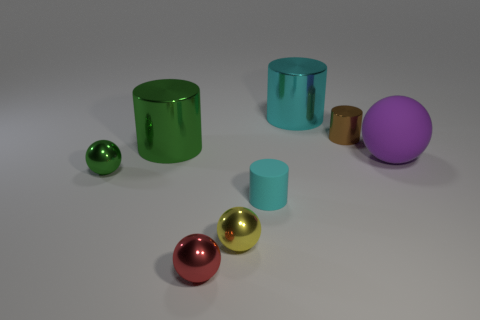Subtract all large cyan metallic cylinders. How many cylinders are left? 3 Add 1 brown shiny things. How many objects exist? 9 Subtract all cyan cylinders. How many cylinders are left? 2 Subtract all purple cubes. How many yellow balls are left? 1 Subtract all cyan balls. Subtract all blue blocks. How many balls are left? 4 Subtract all green objects. Subtract all purple rubber objects. How many objects are left? 5 Add 6 tiny cyan rubber objects. How many tiny cyan rubber objects are left? 7 Add 5 small yellow spheres. How many small yellow spheres exist? 6 Subtract 0 blue spheres. How many objects are left? 8 Subtract 3 balls. How many balls are left? 1 